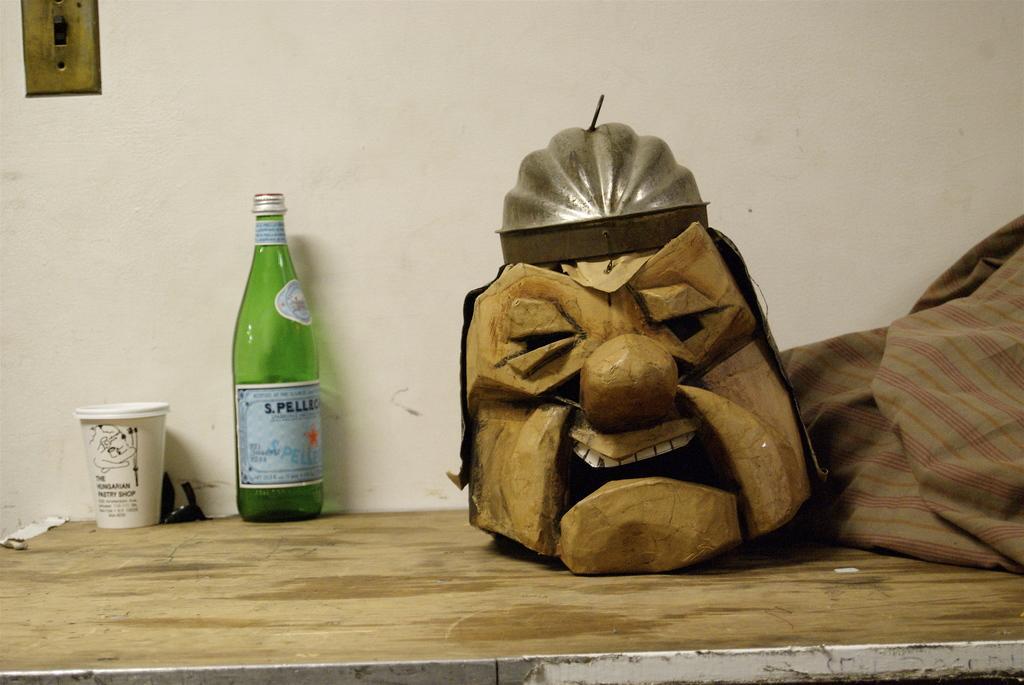Describe this image in one or two sentences. This picture is taken in room. Here, we see a table on which green bottle, caps, a cloth and wooden carving are placed on it. Behind that, we see a white wall. 